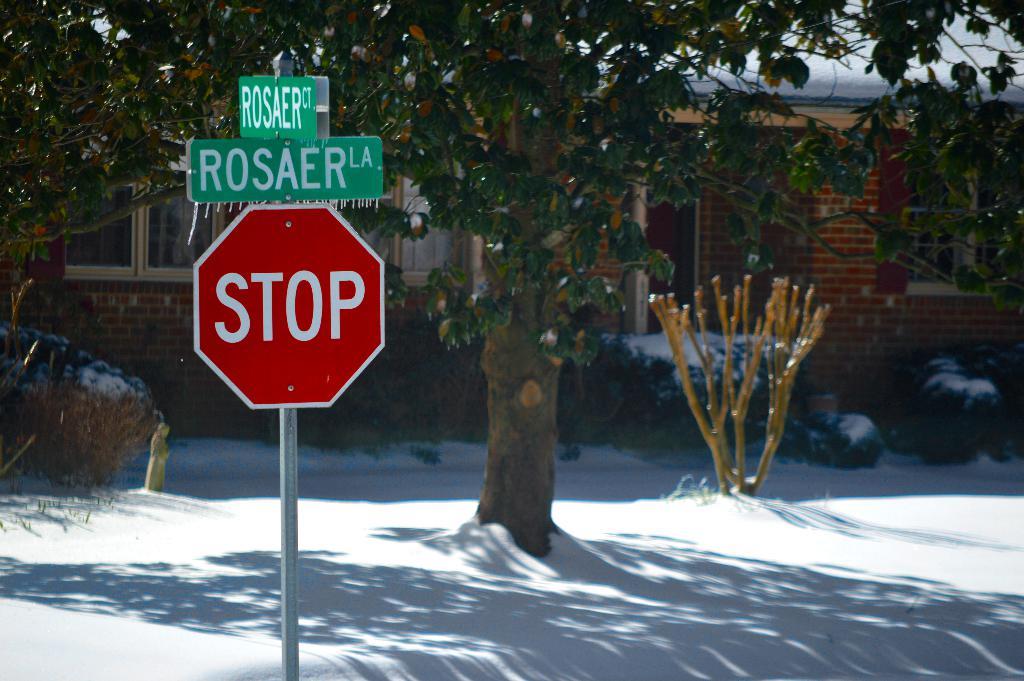What is the street name?
Offer a very short reply. Rosaer. What instruction does the red sign give to drivers?
Your answer should be compact. Stop. 